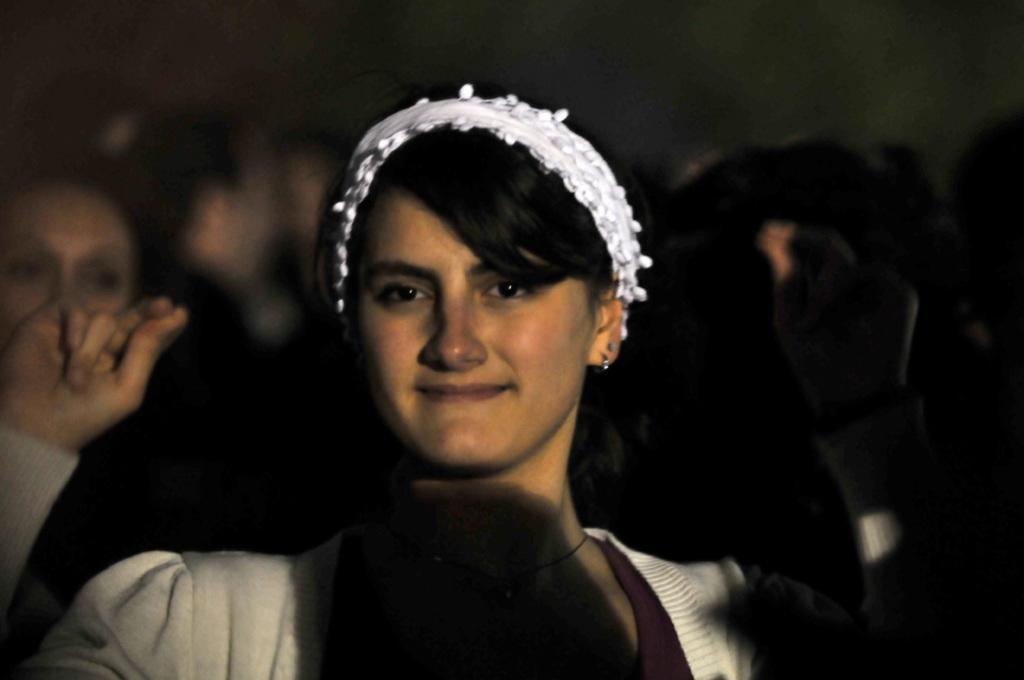How would you summarize this image in a sentence or two? In this picture we can see a woman, she is smiling and in the background we can see people and it is dark. 